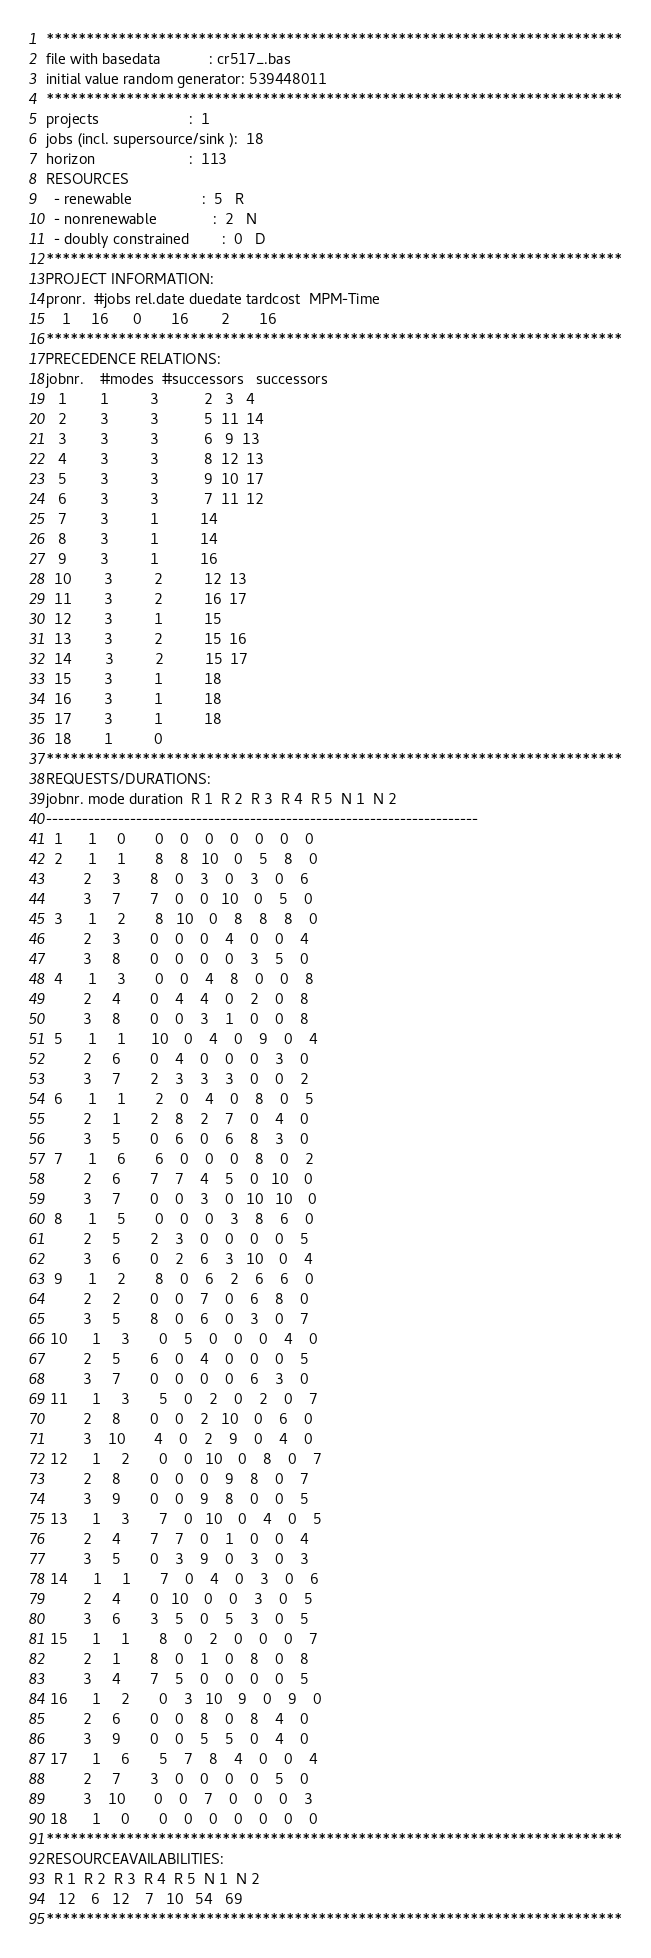Convert code to text. <code><loc_0><loc_0><loc_500><loc_500><_ObjectiveC_>************************************************************************
file with basedata            : cr517_.bas
initial value random generator: 539448011
************************************************************************
projects                      :  1
jobs (incl. supersource/sink ):  18
horizon                       :  113
RESOURCES
  - renewable                 :  5   R
  - nonrenewable              :  2   N
  - doubly constrained        :  0   D
************************************************************************
PROJECT INFORMATION:
pronr.  #jobs rel.date duedate tardcost  MPM-Time
    1     16      0       16        2       16
************************************************************************
PRECEDENCE RELATIONS:
jobnr.    #modes  #successors   successors
   1        1          3           2   3   4
   2        3          3           5  11  14
   3        3          3           6   9  13
   4        3          3           8  12  13
   5        3          3           9  10  17
   6        3          3           7  11  12
   7        3          1          14
   8        3          1          14
   9        3          1          16
  10        3          2          12  13
  11        3          2          16  17
  12        3          1          15
  13        3          2          15  16
  14        3          2          15  17
  15        3          1          18
  16        3          1          18
  17        3          1          18
  18        1          0        
************************************************************************
REQUESTS/DURATIONS:
jobnr. mode duration  R 1  R 2  R 3  R 4  R 5  N 1  N 2
------------------------------------------------------------------------
  1      1     0       0    0    0    0    0    0    0
  2      1     1       8    8   10    0    5    8    0
         2     3       8    0    3    0    3    0    6
         3     7       7    0    0   10    0    5    0
  3      1     2       8   10    0    8    8    8    0
         2     3       0    0    0    4    0    0    4
         3     8       0    0    0    0    3    5    0
  4      1     3       0    0    4    8    0    0    8
         2     4       0    4    4    0    2    0    8
         3     8       0    0    3    1    0    0    8
  5      1     1      10    0    4    0    9    0    4
         2     6       0    4    0    0    0    3    0
         3     7       2    3    3    3    0    0    2
  6      1     1       2    0    4    0    8    0    5
         2     1       2    8    2    7    0    4    0
         3     5       0    6    0    6    8    3    0
  7      1     6       6    0    0    0    8    0    2
         2     6       7    7    4    5    0   10    0
         3     7       0    0    3    0   10   10    0
  8      1     5       0    0    0    3    8    6    0
         2     5       2    3    0    0    0    0    5
         3     6       0    2    6    3   10    0    4
  9      1     2       8    0    6    2    6    6    0
         2     2       0    0    7    0    6    8    0
         3     5       8    0    6    0    3    0    7
 10      1     3       0    5    0    0    0    4    0
         2     5       6    0    4    0    0    0    5
         3     7       0    0    0    0    6    3    0
 11      1     3       5    0    2    0    2    0    7
         2     8       0    0    2   10    0    6    0
         3    10       4    0    2    9    0    4    0
 12      1     2       0    0   10    0    8    0    7
         2     8       0    0    0    9    8    0    7
         3     9       0    0    9    8    0    0    5
 13      1     3       7    0   10    0    4    0    5
         2     4       7    7    0    1    0    0    4
         3     5       0    3    9    0    3    0    3
 14      1     1       7    0    4    0    3    0    6
         2     4       0   10    0    0    3    0    5
         3     6       3    5    0    5    3    0    5
 15      1     1       8    0    2    0    0    0    7
         2     1       8    0    1    0    8    0    8
         3     4       7    5    0    0    0    0    5
 16      1     2       0    3   10    9    0    9    0
         2     6       0    0    8    0    8    4    0
         3     9       0    0    5    5    0    4    0
 17      1     6       5    7    8    4    0    0    4
         2     7       3    0    0    0    0    5    0
         3    10       0    0    7    0    0    0    3
 18      1     0       0    0    0    0    0    0    0
************************************************************************
RESOURCEAVAILABILITIES:
  R 1  R 2  R 3  R 4  R 5  N 1  N 2
   12    6   12    7   10   54   69
************************************************************************
</code> 